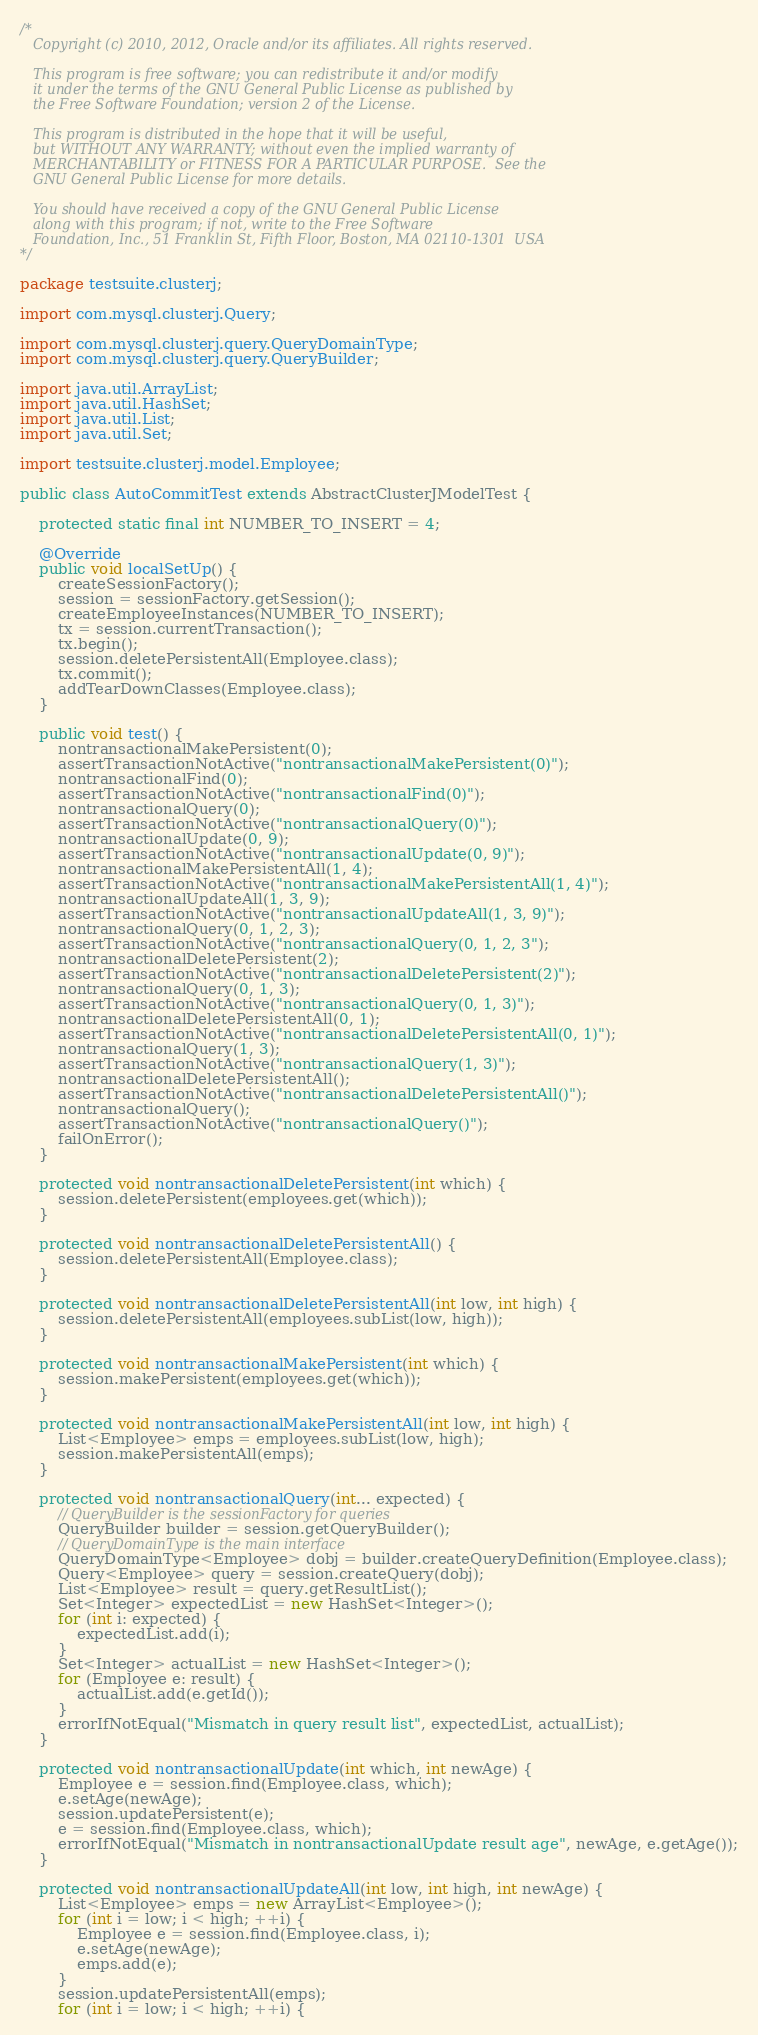<code> <loc_0><loc_0><loc_500><loc_500><_Java_>/*
   Copyright (c) 2010, 2012, Oracle and/or its affiliates. All rights reserved.

   This program is free software; you can redistribute it and/or modify
   it under the terms of the GNU General Public License as published by
   the Free Software Foundation; version 2 of the License.

   This program is distributed in the hope that it will be useful,
   but WITHOUT ANY WARRANTY; without even the implied warranty of
   MERCHANTABILITY or FITNESS FOR A PARTICULAR PURPOSE.  See the
   GNU General Public License for more details.

   You should have received a copy of the GNU General Public License
   along with this program; if not, write to the Free Software
   Foundation, Inc., 51 Franklin St, Fifth Floor, Boston, MA 02110-1301  USA
*/

package testsuite.clusterj;

import com.mysql.clusterj.Query;

import com.mysql.clusterj.query.QueryDomainType;
import com.mysql.clusterj.query.QueryBuilder;

import java.util.ArrayList;
import java.util.HashSet;
import java.util.List;
import java.util.Set;

import testsuite.clusterj.model.Employee;

public class AutoCommitTest extends AbstractClusterJModelTest {

    protected static final int NUMBER_TO_INSERT = 4;

    @Override
    public void localSetUp() {
        createSessionFactory();
        session = sessionFactory.getSession();
        createEmployeeInstances(NUMBER_TO_INSERT);
        tx = session.currentTransaction();
        tx.begin();
        session.deletePersistentAll(Employee.class);
        tx.commit();
        addTearDownClasses(Employee.class);
    }

    public void test() {
        nontransactionalMakePersistent(0);
        assertTransactionNotActive("nontransactionalMakePersistent(0)");
        nontransactionalFind(0);
        assertTransactionNotActive("nontransactionalFind(0)");
        nontransactionalQuery(0);
        assertTransactionNotActive("nontransactionalQuery(0)");
        nontransactionalUpdate(0, 9);
        assertTransactionNotActive("nontransactionalUpdate(0, 9)");
        nontransactionalMakePersistentAll(1, 4);
        assertTransactionNotActive("nontransactionalMakePersistentAll(1, 4)");
        nontransactionalUpdateAll(1, 3, 9);
        assertTransactionNotActive("nontransactionalUpdateAll(1, 3, 9)");
        nontransactionalQuery(0, 1, 2, 3);
        assertTransactionNotActive("nontransactionalQuery(0, 1, 2, 3");
        nontransactionalDeletePersistent(2);
        assertTransactionNotActive("nontransactionalDeletePersistent(2)");
        nontransactionalQuery(0, 1, 3);
        assertTransactionNotActive("nontransactionalQuery(0, 1, 3)");
        nontransactionalDeletePersistentAll(0, 1);
        assertTransactionNotActive("nontransactionalDeletePersistentAll(0, 1)");
        nontransactionalQuery(1, 3);
        assertTransactionNotActive("nontransactionalQuery(1, 3)");
        nontransactionalDeletePersistentAll();
        assertTransactionNotActive("nontransactionalDeletePersistentAll()");
        nontransactionalQuery();
        assertTransactionNotActive("nontransactionalQuery()");
        failOnError();
    }

    protected void nontransactionalDeletePersistent(int which) {
        session.deletePersistent(employees.get(which));
    }

    protected void nontransactionalDeletePersistentAll() {
        session.deletePersistentAll(Employee.class);
    }

    protected void nontransactionalDeletePersistentAll(int low, int high) {
        session.deletePersistentAll(employees.subList(low, high));
    }

    protected void nontransactionalMakePersistent(int which) {
        session.makePersistent(employees.get(which));
    }

    protected void nontransactionalMakePersistentAll(int low, int high) {
        List<Employee> emps = employees.subList(low, high);
        session.makePersistentAll(emps);
    }

    protected void nontransactionalQuery(int... expected) {
        // QueryBuilder is the sessionFactory for queries
        QueryBuilder builder = session.getQueryBuilder();
        // QueryDomainType is the main interface
        QueryDomainType<Employee> dobj = builder.createQueryDefinition(Employee.class);
        Query<Employee> query = session.createQuery(dobj);
        List<Employee> result = query.getResultList();
        Set<Integer> expectedList = new HashSet<Integer>();
        for (int i: expected) {
            expectedList.add(i);
        }
        Set<Integer> actualList = new HashSet<Integer>();
        for (Employee e: result) {
            actualList.add(e.getId());
        }
        errorIfNotEqual("Mismatch in query result list", expectedList, actualList);
    }

    protected void nontransactionalUpdate(int which, int newAge) {
        Employee e = session.find(Employee.class, which);
        e.setAge(newAge);
        session.updatePersistent(e);
        e = session.find(Employee.class, which);
        errorIfNotEqual("Mismatch in nontransactionalUpdate result age", newAge, e.getAge());
    }

    protected void nontransactionalUpdateAll(int low, int high, int newAge) {
        List<Employee> emps = new ArrayList<Employee>();
        for (int i = low; i < high; ++i) {
            Employee e = session.find(Employee.class, i);
            e.setAge(newAge);
            emps.add(e);
        }
        session.updatePersistentAll(emps);
        for (int i = low; i < high; ++i) {</code> 